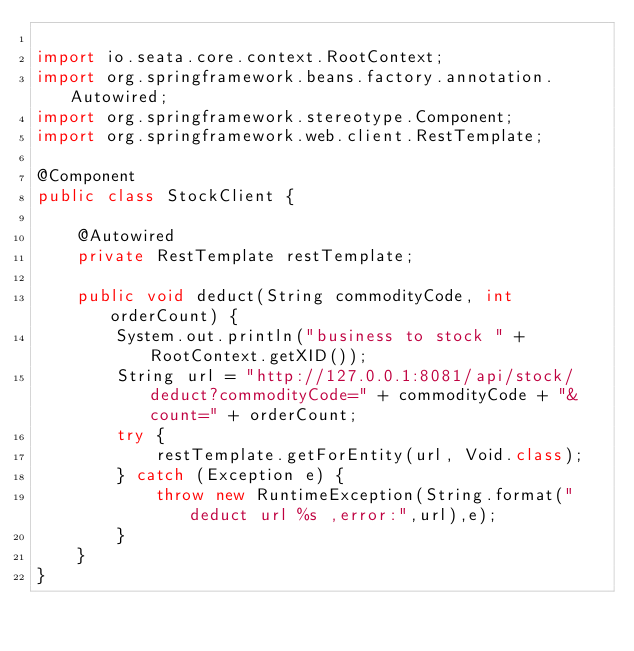Convert code to text. <code><loc_0><loc_0><loc_500><loc_500><_Java_>
import io.seata.core.context.RootContext;
import org.springframework.beans.factory.annotation.Autowired;
import org.springframework.stereotype.Component;
import org.springframework.web.client.RestTemplate;

@Component
public class StockClient {

    @Autowired
    private RestTemplate restTemplate;

    public void deduct(String commodityCode, int orderCount) {
        System.out.println("business to stock " + RootContext.getXID());
        String url = "http://127.0.0.1:8081/api/stock/deduct?commodityCode=" + commodityCode + "&count=" + orderCount;
        try {
            restTemplate.getForEntity(url, Void.class);
        } catch (Exception e) {
            throw new RuntimeException(String.format("deduct url %s ,error:",url),e);
        }
    }
}
</code> 